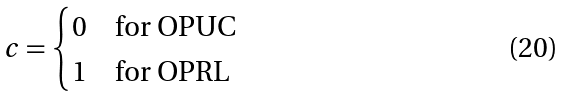Convert formula to latex. <formula><loc_0><loc_0><loc_500><loc_500>c = \begin{cases} 0 & \text {for OPUC} \\ 1 & \text {for OPRL} \end{cases}</formula> 